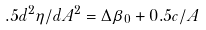<formula> <loc_0><loc_0><loc_500><loc_500>. 5 d ^ { 2 } \eta / d A ^ { 2 } = \Delta \beta _ { 0 } + 0 . 5 c / A</formula> 